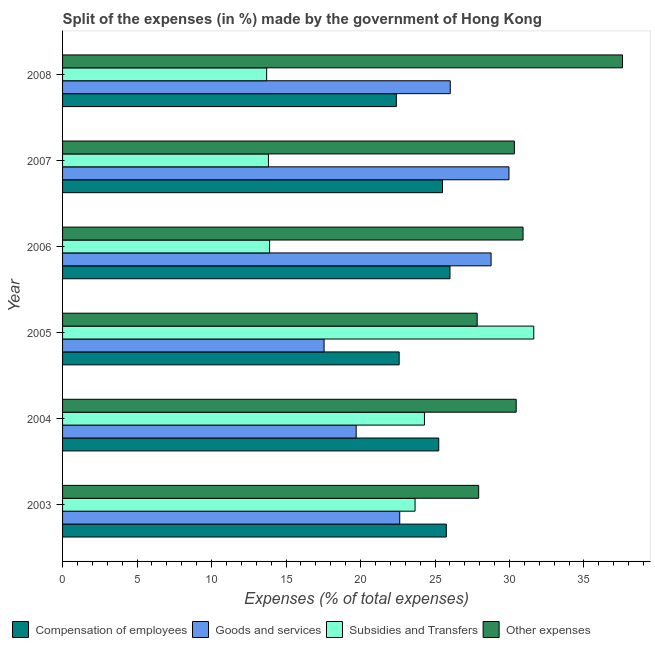How many different coloured bars are there?
Your response must be concise. 4. How many groups of bars are there?
Offer a terse response. 6. How many bars are there on the 5th tick from the bottom?
Ensure brevity in your answer.  4. In how many cases, is the number of bars for a given year not equal to the number of legend labels?
Keep it short and to the point. 0. What is the percentage of amount spent on goods and services in 2008?
Offer a terse response. 26.02. Across all years, what is the maximum percentage of amount spent on subsidies?
Your response must be concise. 31.63. Across all years, what is the minimum percentage of amount spent on other expenses?
Give a very brief answer. 27.83. In which year was the percentage of amount spent on compensation of employees maximum?
Make the answer very short. 2006. In which year was the percentage of amount spent on other expenses minimum?
Your response must be concise. 2005. What is the total percentage of amount spent on subsidies in the graph?
Offer a terse response. 121. What is the difference between the percentage of amount spent on subsidies in 2005 and that in 2008?
Your response must be concise. 17.93. What is the difference between the percentage of amount spent on subsidies in 2008 and the percentage of amount spent on other expenses in 2005?
Provide a succinct answer. -14.13. What is the average percentage of amount spent on subsidies per year?
Make the answer very short. 20.17. In the year 2006, what is the difference between the percentage of amount spent on subsidies and percentage of amount spent on other expenses?
Make the answer very short. -17.01. In how many years, is the percentage of amount spent on goods and services greater than 11 %?
Give a very brief answer. 6. Is the difference between the percentage of amount spent on goods and services in 2006 and 2007 greater than the difference between the percentage of amount spent on subsidies in 2006 and 2007?
Offer a very short reply. No. What is the difference between the highest and the second highest percentage of amount spent on goods and services?
Offer a terse response. 1.2. What is the difference between the highest and the lowest percentage of amount spent on goods and services?
Your answer should be compact. 12.41. Is it the case that in every year, the sum of the percentage of amount spent on compensation of employees and percentage of amount spent on goods and services is greater than the sum of percentage of amount spent on other expenses and percentage of amount spent on subsidies?
Your answer should be compact. Yes. What does the 2nd bar from the top in 2006 represents?
Keep it short and to the point. Subsidies and Transfers. What does the 1st bar from the bottom in 2004 represents?
Offer a very short reply. Compensation of employees. Is it the case that in every year, the sum of the percentage of amount spent on compensation of employees and percentage of amount spent on goods and services is greater than the percentage of amount spent on subsidies?
Your response must be concise. Yes. How many bars are there?
Make the answer very short. 24. Are all the bars in the graph horizontal?
Ensure brevity in your answer.  Yes. Does the graph contain grids?
Keep it short and to the point. No. Where does the legend appear in the graph?
Your response must be concise. Bottom left. What is the title of the graph?
Ensure brevity in your answer.  Split of the expenses (in %) made by the government of Hong Kong. Does "Greece" appear as one of the legend labels in the graph?
Keep it short and to the point. No. What is the label or title of the X-axis?
Give a very brief answer. Expenses (% of total expenses). What is the label or title of the Y-axis?
Keep it short and to the point. Year. What is the Expenses (% of total expenses) in Compensation of employees in 2003?
Your response must be concise. 25.76. What is the Expenses (% of total expenses) in Goods and services in 2003?
Make the answer very short. 22.63. What is the Expenses (% of total expenses) of Subsidies and Transfers in 2003?
Keep it short and to the point. 23.66. What is the Expenses (% of total expenses) in Other expenses in 2003?
Your answer should be compact. 27.93. What is the Expenses (% of total expenses) in Compensation of employees in 2004?
Offer a terse response. 25.25. What is the Expenses (% of total expenses) of Goods and services in 2004?
Your response must be concise. 19.71. What is the Expenses (% of total expenses) in Subsidies and Transfers in 2004?
Offer a terse response. 24.29. What is the Expenses (% of total expenses) of Other expenses in 2004?
Keep it short and to the point. 30.45. What is the Expenses (% of total expenses) in Compensation of employees in 2005?
Provide a succinct answer. 22.59. What is the Expenses (% of total expenses) of Goods and services in 2005?
Offer a very short reply. 17.56. What is the Expenses (% of total expenses) of Subsidies and Transfers in 2005?
Make the answer very short. 31.63. What is the Expenses (% of total expenses) of Other expenses in 2005?
Ensure brevity in your answer.  27.83. What is the Expenses (% of total expenses) in Compensation of employees in 2006?
Ensure brevity in your answer.  26.01. What is the Expenses (% of total expenses) in Goods and services in 2006?
Provide a succinct answer. 28.76. What is the Expenses (% of total expenses) in Subsidies and Transfers in 2006?
Your answer should be very brief. 13.9. What is the Expenses (% of total expenses) in Other expenses in 2006?
Offer a very short reply. 30.91. What is the Expenses (% of total expenses) in Compensation of employees in 2007?
Ensure brevity in your answer.  25.5. What is the Expenses (% of total expenses) of Goods and services in 2007?
Offer a very short reply. 29.97. What is the Expenses (% of total expenses) of Subsidies and Transfers in 2007?
Give a very brief answer. 13.82. What is the Expenses (% of total expenses) of Other expenses in 2007?
Your answer should be compact. 30.33. What is the Expenses (% of total expenses) of Compensation of employees in 2008?
Offer a very short reply. 22.41. What is the Expenses (% of total expenses) in Goods and services in 2008?
Your answer should be very brief. 26.02. What is the Expenses (% of total expenses) in Subsidies and Transfers in 2008?
Ensure brevity in your answer.  13.7. What is the Expenses (% of total expenses) in Other expenses in 2008?
Make the answer very short. 37.59. Across all years, what is the maximum Expenses (% of total expenses) in Compensation of employees?
Keep it short and to the point. 26.01. Across all years, what is the maximum Expenses (% of total expenses) in Goods and services?
Offer a very short reply. 29.97. Across all years, what is the maximum Expenses (% of total expenses) of Subsidies and Transfers?
Your answer should be compact. 31.63. Across all years, what is the maximum Expenses (% of total expenses) in Other expenses?
Your answer should be compact. 37.59. Across all years, what is the minimum Expenses (% of total expenses) of Compensation of employees?
Your answer should be very brief. 22.41. Across all years, what is the minimum Expenses (% of total expenses) of Goods and services?
Provide a short and direct response. 17.56. Across all years, what is the minimum Expenses (% of total expenses) of Subsidies and Transfers?
Provide a short and direct response. 13.7. Across all years, what is the minimum Expenses (% of total expenses) in Other expenses?
Offer a terse response. 27.83. What is the total Expenses (% of total expenses) in Compensation of employees in the graph?
Ensure brevity in your answer.  147.52. What is the total Expenses (% of total expenses) in Goods and services in the graph?
Make the answer very short. 144.65. What is the total Expenses (% of total expenses) in Subsidies and Transfers in the graph?
Keep it short and to the point. 121. What is the total Expenses (% of total expenses) in Other expenses in the graph?
Your response must be concise. 185.04. What is the difference between the Expenses (% of total expenses) of Compensation of employees in 2003 and that in 2004?
Give a very brief answer. 0.51. What is the difference between the Expenses (% of total expenses) in Goods and services in 2003 and that in 2004?
Your response must be concise. 2.92. What is the difference between the Expenses (% of total expenses) in Subsidies and Transfers in 2003 and that in 2004?
Offer a very short reply. -0.63. What is the difference between the Expenses (% of total expenses) in Other expenses in 2003 and that in 2004?
Offer a terse response. -2.52. What is the difference between the Expenses (% of total expenses) of Compensation of employees in 2003 and that in 2005?
Your response must be concise. 3.17. What is the difference between the Expenses (% of total expenses) of Goods and services in 2003 and that in 2005?
Provide a short and direct response. 5.08. What is the difference between the Expenses (% of total expenses) in Subsidies and Transfers in 2003 and that in 2005?
Your response must be concise. -7.97. What is the difference between the Expenses (% of total expenses) in Other expenses in 2003 and that in 2005?
Provide a short and direct response. 0.1. What is the difference between the Expenses (% of total expenses) of Compensation of employees in 2003 and that in 2006?
Your answer should be compact. -0.25. What is the difference between the Expenses (% of total expenses) in Goods and services in 2003 and that in 2006?
Make the answer very short. -6.13. What is the difference between the Expenses (% of total expenses) in Subsidies and Transfers in 2003 and that in 2006?
Your answer should be very brief. 9.76. What is the difference between the Expenses (% of total expenses) in Other expenses in 2003 and that in 2006?
Your answer should be compact. -2.98. What is the difference between the Expenses (% of total expenses) of Compensation of employees in 2003 and that in 2007?
Keep it short and to the point. 0.26. What is the difference between the Expenses (% of total expenses) of Goods and services in 2003 and that in 2007?
Provide a succinct answer. -7.33. What is the difference between the Expenses (% of total expenses) in Subsidies and Transfers in 2003 and that in 2007?
Offer a very short reply. 9.84. What is the difference between the Expenses (% of total expenses) in Other expenses in 2003 and that in 2007?
Offer a very short reply. -2.39. What is the difference between the Expenses (% of total expenses) of Compensation of employees in 2003 and that in 2008?
Provide a succinct answer. 3.36. What is the difference between the Expenses (% of total expenses) of Goods and services in 2003 and that in 2008?
Make the answer very short. -3.39. What is the difference between the Expenses (% of total expenses) of Subsidies and Transfers in 2003 and that in 2008?
Keep it short and to the point. 9.96. What is the difference between the Expenses (% of total expenses) of Other expenses in 2003 and that in 2008?
Provide a succinct answer. -9.65. What is the difference between the Expenses (% of total expenses) in Compensation of employees in 2004 and that in 2005?
Provide a short and direct response. 2.66. What is the difference between the Expenses (% of total expenses) of Goods and services in 2004 and that in 2005?
Make the answer very short. 2.15. What is the difference between the Expenses (% of total expenses) in Subsidies and Transfers in 2004 and that in 2005?
Keep it short and to the point. -7.34. What is the difference between the Expenses (% of total expenses) of Other expenses in 2004 and that in 2005?
Ensure brevity in your answer.  2.62. What is the difference between the Expenses (% of total expenses) in Compensation of employees in 2004 and that in 2006?
Make the answer very short. -0.76. What is the difference between the Expenses (% of total expenses) in Goods and services in 2004 and that in 2006?
Offer a very short reply. -9.05. What is the difference between the Expenses (% of total expenses) in Subsidies and Transfers in 2004 and that in 2006?
Your answer should be compact. 10.39. What is the difference between the Expenses (% of total expenses) of Other expenses in 2004 and that in 2006?
Your answer should be very brief. -0.46. What is the difference between the Expenses (% of total expenses) in Compensation of employees in 2004 and that in 2007?
Give a very brief answer. -0.25. What is the difference between the Expenses (% of total expenses) of Goods and services in 2004 and that in 2007?
Your response must be concise. -10.26. What is the difference between the Expenses (% of total expenses) of Subsidies and Transfers in 2004 and that in 2007?
Your answer should be compact. 10.47. What is the difference between the Expenses (% of total expenses) of Other expenses in 2004 and that in 2007?
Offer a terse response. 0.12. What is the difference between the Expenses (% of total expenses) in Compensation of employees in 2004 and that in 2008?
Give a very brief answer. 2.85. What is the difference between the Expenses (% of total expenses) of Goods and services in 2004 and that in 2008?
Offer a very short reply. -6.32. What is the difference between the Expenses (% of total expenses) in Subsidies and Transfers in 2004 and that in 2008?
Your response must be concise. 10.59. What is the difference between the Expenses (% of total expenses) of Other expenses in 2004 and that in 2008?
Make the answer very short. -7.13. What is the difference between the Expenses (% of total expenses) of Compensation of employees in 2005 and that in 2006?
Offer a very short reply. -3.41. What is the difference between the Expenses (% of total expenses) in Goods and services in 2005 and that in 2006?
Give a very brief answer. -11.21. What is the difference between the Expenses (% of total expenses) of Subsidies and Transfers in 2005 and that in 2006?
Provide a succinct answer. 17.73. What is the difference between the Expenses (% of total expenses) of Other expenses in 2005 and that in 2006?
Your answer should be very brief. -3.08. What is the difference between the Expenses (% of total expenses) of Compensation of employees in 2005 and that in 2007?
Give a very brief answer. -2.91. What is the difference between the Expenses (% of total expenses) in Goods and services in 2005 and that in 2007?
Keep it short and to the point. -12.41. What is the difference between the Expenses (% of total expenses) of Subsidies and Transfers in 2005 and that in 2007?
Provide a short and direct response. 17.81. What is the difference between the Expenses (% of total expenses) of Other expenses in 2005 and that in 2007?
Make the answer very short. -2.5. What is the difference between the Expenses (% of total expenses) of Compensation of employees in 2005 and that in 2008?
Give a very brief answer. 0.19. What is the difference between the Expenses (% of total expenses) of Goods and services in 2005 and that in 2008?
Your response must be concise. -8.47. What is the difference between the Expenses (% of total expenses) of Subsidies and Transfers in 2005 and that in 2008?
Offer a very short reply. 17.93. What is the difference between the Expenses (% of total expenses) of Other expenses in 2005 and that in 2008?
Your response must be concise. -9.76. What is the difference between the Expenses (% of total expenses) of Compensation of employees in 2006 and that in 2007?
Keep it short and to the point. 0.5. What is the difference between the Expenses (% of total expenses) in Goods and services in 2006 and that in 2007?
Ensure brevity in your answer.  -1.2. What is the difference between the Expenses (% of total expenses) of Subsidies and Transfers in 2006 and that in 2007?
Your answer should be compact. 0.08. What is the difference between the Expenses (% of total expenses) of Other expenses in 2006 and that in 2007?
Your response must be concise. 0.58. What is the difference between the Expenses (% of total expenses) of Compensation of employees in 2006 and that in 2008?
Provide a short and direct response. 3.6. What is the difference between the Expenses (% of total expenses) in Goods and services in 2006 and that in 2008?
Offer a terse response. 2.74. What is the difference between the Expenses (% of total expenses) in Subsidies and Transfers in 2006 and that in 2008?
Provide a succinct answer. 0.2. What is the difference between the Expenses (% of total expenses) in Other expenses in 2006 and that in 2008?
Keep it short and to the point. -6.68. What is the difference between the Expenses (% of total expenses) in Compensation of employees in 2007 and that in 2008?
Your response must be concise. 3.1. What is the difference between the Expenses (% of total expenses) in Goods and services in 2007 and that in 2008?
Provide a succinct answer. 3.94. What is the difference between the Expenses (% of total expenses) in Subsidies and Transfers in 2007 and that in 2008?
Provide a short and direct response. 0.12. What is the difference between the Expenses (% of total expenses) of Other expenses in 2007 and that in 2008?
Give a very brief answer. -7.26. What is the difference between the Expenses (% of total expenses) in Compensation of employees in 2003 and the Expenses (% of total expenses) in Goods and services in 2004?
Provide a succinct answer. 6.05. What is the difference between the Expenses (% of total expenses) of Compensation of employees in 2003 and the Expenses (% of total expenses) of Subsidies and Transfers in 2004?
Offer a terse response. 1.47. What is the difference between the Expenses (% of total expenses) of Compensation of employees in 2003 and the Expenses (% of total expenses) of Other expenses in 2004?
Your response must be concise. -4.69. What is the difference between the Expenses (% of total expenses) in Goods and services in 2003 and the Expenses (% of total expenses) in Subsidies and Transfers in 2004?
Offer a terse response. -1.66. What is the difference between the Expenses (% of total expenses) of Goods and services in 2003 and the Expenses (% of total expenses) of Other expenses in 2004?
Give a very brief answer. -7.82. What is the difference between the Expenses (% of total expenses) in Subsidies and Transfers in 2003 and the Expenses (% of total expenses) in Other expenses in 2004?
Provide a short and direct response. -6.79. What is the difference between the Expenses (% of total expenses) of Compensation of employees in 2003 and the Expenses (% of total expenses) of Goods and services in 2005?
Provide a short and direct response. 8.21. What is the difference between the Expenses (% of total expenses) of Compensation of employees in 2003 and the Expenses (% of total expenses) of Subsidies and Transfers in 2005?
Offer a very short reply. -5.87. What is the difference between the Expenses (% of total expenses) in Compensation of employees in 2003 and the Expenses (% of total expenses) in Other expenses in 2005?
Ensure brevity in your answer.  -2.07. What is the difference between the Expenses (% of total expenses) in Goods and services in 2003 and the Expenses (% of total expenses) in Subsidies and Transfers in 2005?
Offer a very short reply. -9. What is the difference between the Expenses (% of total expenses) of Goods and services in 2003 and the Expenses (% of total expenses) of Other expenses in 2005?
Provide a short and direct response. -5.2. What is the difference between the Expenses (% of total expenses) of Subsidies and Transfers in 2003 and the Expenses (% of total expenses) of Other expenses in 2005?
Your response must be concise. -4.17. What is the difference between the Expenses (% of total expenses) in Compensation of employees in 2003 and the Expenses (% of total expenses) in Goods and services in 2006?
Offer a terse response. -3. What is the difference between the Expenses (% of total expenses) in Compensation of employees in 2003 and the Expenses (% of total expenses) in Subsidies and Transfers in 2006?
Keep it short and to the point. 11.86. What is the difference between the Expenses (% of total expenses) of Compensation of employees in 2003 and the Expenses (% of total expenses) of Other expenses in 2006?
Your answer should be compact. -5.15. What is the difference between the Expenses (% of total expenses) in Goods and services in 2003 and the Expenses (% of total expenses) in Subsidies and Transfers in 2006?
Keep it short and to the point. 8.73. What is the difference between the Expenses (% of total expenses) of Goods and services in 2003 and the Expenses (% of total expenses) of Other expenses in 2006?
Keep it short and to the point. -8.28. What is the difference between the Expenses (% of total expenses) of Subsidies and Transfers in 2003 and the Expenses (% of total expenses) of Other expenses in 2006?
Ensure brevity in your answer.  -7.25. What is the difference between the Expenses (% of total expenses) in Compensation of employees in 2003 and the Expenses (% of total expenses) in Goods and services in 2007?
Provide a short and direct response. -4.2. What is the difference between the Expenses (% of total expenses) in Compensation of employees in 2003 and the Expenses (% of total expenses) in Subsidies and Transfers in 2007?
Provide a succinct answer. 11.94. What is the difference between the Expenses (% of total expenses) in Compensation of employees in 2003 and the Expenses (% of total expenses) in Other expenses in 2007?
Provide a short and direct response. -4.57. What is the difference between the Expenses (% of total expenses) of Goods and services in 2003 and the Expenses (% of total expenses) of Subsidies and Transfers in 2007?
Your response must be concise. 8.81. What is the difference between the Expenses (% of total expenses) of Goods and services in 2003 and the Expenses (% of total expenses) of Other expenses in 2007?
Offer a terse response. -7.69. What is the difference between the Expenses (% of total expenses) in Subsidies and Transfers in 2003 and the Expenses (% of total expenses) in Other expenses in 2007?
Offer a very short reply. -6.67. What is the difference between the Expenses (% of total expenses) in Compensation of employees in 2003 and the Expenses (% of total expenses) in Goods and services in 2008?
Provide a succinct answer. -0.26. What is the difference between the Expenses (% of total expenses) of Compensation of employees in 2003 and the Expenses (% of total expenses) of Subsidies and Transfers in 2008?
Ensure brevity in your answer.  12.06. What is the difference between the Expenses (% of total expenses) in Compensation of employees in 2003 and the Expenses (% of total expenses) in Other expenses in 2008?
Ensure brevity in your answer.  -11.83. What is the difference between the Expenses (% of total expenses) of Goods and services in 2003 and the Expenses (% of total expenses) of Subsidies and Transfers in 2008?
Provide a succinct answer. 8.93. What is the difference between the Expenses (% of total expenses) in Goods and services in 2003 and the Expenses (% of total expenses) in Other expenses in 2008?
Your response must be concise. -14.95. What is the difference between the Expenses (% of total expenses) in Subsidies and Transfers in 2003 and the Expenses (% of total expenses) in Other expenses in 2008?
Keep it short and to the point. -13.92. What is the difference between the Expenses (% of total expenses) in Compensation of employees in 2004 and the Expenses (% of total expenses) in Goods and services in 2005?
Provide a short and direct response. 7.7. What is the difference between the Expenses (% of total expenses) in Compensation of employees in 2004 and the Expenses (% of total expenses) in Subsidies and Transfers in 2005?
Offer a very short reply. -6.38. What is the difference between the Expenses (% of total expenses) in Compensation of employees in 2004 and the Expenses (% of total expenses) in Other expenses in 2005?
Offer a terse response. -2.58. What is the difference between the Expenses (% of total expenses) of Goods and services in 2004 and the Expenses (% of total expenses) of Subsidies and Transfers in 2005?
Make the answer very short. -11.92. What is the difference between the Expenses (% of total expenses) in Goods and services in 2004 and the Expenses (% of total expenses) in Other expenses in 2005?
Your answer should be very brief. -8.12. What is the difference between the Expenses (% of total expenses) of Subsidies and Transfers in 2004 and the Expenses (% of total expenses) of Other expenses in 2005?
Give a very brief answer. -3.54. What is the difference between the Expenses (% of total expenses) in Compensation of employees in 2004 and the Expenses (% of total expenses) in Goods and services in 2006?
Your answer should be compact. -3.51. What is the difference between the Expenses (% of total expenses) in Compensation of employees in 2004 and the Expenses (% of total expenses) in Subsidies and Transfers in 2006?
Your answer should be compact. 11.35. What is the difference between the Expenses (% of total expenses) in Compensation of employees in 2004 and the Expenses (% of total expenses) in Other expenses in 2006?
Offer a terse response. -5.66. What is the difference between the Expenses (% of total expenses) in Goods and services in 2004 and the Expenses (% of total expenses) in Subsidies and Transfers in 2006?
Make the answer very short. 5.81. What is the difference between the Expenses (% of total expenses) in Goods and services in 2004 and the Expenses (% of total expenses) in Other expenses in 2006?
Ensure brevity in your answer.  -11.2. What is the difference between the Expenses (% of total expenses) in Subsidies and Transfers in 2004 and the Expenses (% of total expenses) in Other expenses in 2006?
Make the answer very short. -6.62. What is the difference between the Expenses (% of total expenses) of Compensation of employees in 2004 and the Expenses (% of total expenses) of Goods and services in 2007?
Ensure brevity in your answer.  -4.71. What is the difference between the Expenses (% of total expenses) of Compensation of employees in 2004 and the Expenses (% of total expenses) of Subsidies and Transfers in 2007?
Make the answer very short. 11.43. What is the difference between the Expenses (% of total expenses) of Compensation of employees in 2004 and the Expenses (% of total expenses) of Other expenses in 2007?
Provide a short and direct response. -5.08. What is the difference between the Expenses (% of total expenses) in Goods and services in 2004 and the Expenses (% of total expenses) in Subsidies and Transfers in 2007?
Your response must be concise. 5.89. What is the difference between the Expenses (% of total expenses) of Goods and services in 2004 and the Expenses (% of total expenses) of Other expenses in 2007?
Give a very brief answer. -10.62. What is the difference between the Expenses (% of total expenses) of Subsidies and Transfers in 2004 and the Expenses (% of total expenses) of Other expenses in 2007?
Your answer should be very brief. -6.03. What is the difference between the Expenses (% of total expenses) of Compensation of employees in 2004 and the Expenses (% of total expenses) of Goods and services in 2008?
Keep it short and to the point. -0.77. What is the difference between the Expenses (% of total expenses) in Compensation of employees in 2004 and the Expenses (% of total expenses) in Subsidies and Transfers in 2008?
Ensure brevity in your answer.  11.55. What is the difference between the Expenses (% of total expenses) in Compensation of employees in 2004 and the Expenses (% of total expenses) in Other expenses in 2008?
Provide a short and direct response. -12.34. What is the difference between the Expenses (% of total expenses) in Goods and services in 2004 and the Expenses (% of total expenses) in Subsidies and Transfers in 2008?
Give a very brief answer. 6.01. What is the difference between the Expenses (% of total expenses) of Goods and services in 2004 and the Expenses (% of total expenses) of Other expenses in 2008?
Ensure brevity in your answer.  -17.88. What is the difference between the Expenses (% of total expenses) in Subsidies and Transfers in 2004 and the Expenses (% of total expenses) in Other expenses in 2008?
Your response must be concise. -13.29. What is the difference between the Expenses (% of total expenses) of Compensation of employees in 2005 and the Expenses (% of total expenses) of Goods and services in 2006?
Make the answer very short. -6.17. What is the difference between the Expenses (% of total expenses) in Compensation of employees in 2005 and the Expenses (% of total expenses) in Subsidies and Transfers in 2006?
Ensure brevity in your answer.  8.7. What is the difference between the Expenses (% of total expenses) in Compensation of employees in 2005 and the Expenses (% of total expenses) in Other expenses in 2006?
Offer a very short reply. -8.32. What is the difference between the Expenses (% of total expenses) in Goods and services in 2005 and the Expenses (% of total expenses) in Subsidies and Transfers in 2006?
Offer a very short reply. 3.66. What is the difference between the Expenses (% of total expenses) of Goods and services in 2005 and the Expenses (% of total expenses) of Other expenses in 2006?
Your answer should be very brief. -13.35. What is the difference between the Expenses (% of total expenses) of Subsidies and Transfers in 2005 and the Expenses (% of total expenses) of Other expenses in 2006?
Make the answer very short. 0.72. What is the difference between the Expenses (% of total expenses) in Compensation of employees in 2005 and the Expenses (% of total expenses) in Goods and services in 2007?
Ensure brevity in your answer.  -7.37. What is the difference between the Expenses (% of total expenses) in Compensation of employees in 2005 and the Expenses (% of total expenses) in Subsidies and Transfers in 2007?
Offer a very short reply. 8.78. What is the difference between the Expenses (% of total expenses) in Compensation of employees in 2005 and the Expenses (% of total expenses) in Other expenses in 2007?
Keep it short and to the point. -7.73. What is the difference between the Expenses (% of total expenses) in Goods and services in 2005 and the Expenses (% of total expenses) in Subsidies and Transfers in 2007?
Keep it short and to the point. 3.74. What is the difference between the Expenses (% of total expenses) in Goods and services in 2005 and the Expenses (% of total expenses) in Other expenses in 2007?
Your answer should be compact. -12.77. What is the difference between the Expenses (% of total expenses) of Subsidies and Transfers in 2005 and the Expenses (% of total expenses) of Other expenses in 2007?
Give a very brief answer. 1.3. What is the difference between the Expenses (% of total expenses) in Compensation of employees in 2005 and the Expenses (% of total expenses) in Goods and services in 2008?
Make the answer very short. -3.43. What is the difference between the Expenses (% of total expenses) in Compensation of employees in 2005 and the Expenses (% of total expenses) in Subsidies and Transfers in 2008?
Provide a succinct answer. 8.89. What is the difference between the Expenses (% of total expenses) of Compensation of employees in 2005 and the Expenses (% of total expenses) of Other expenses in 2008?
Keep it short and to the point. -14.99. What is the difference between the Expenses (% of total expenses) in Goods and services in 2005 and the Expenses (% of total expenses) in Subsidies and Transfers in 2008?
Give a very brief answer. 3.86. What is the difference between the Expenses (% of total expenses) of Goods and services in 2005 and the Expenses (% of total expenses) of Other expenses in 2008?
Give a very brief answer. -20.03. What is the difference between the Expenses (% of total expenses) in Subsidies and Transfers in 2005 and the Expenses (% of total expenses) in Other expenses in 2008?
Keep it short and to the point. -5.96. What is the difference between the Expenses (% of total expenses) in Compensation of employees in 2006 and the Expenses (% of total expenses) in Goods and services in 2007?
Offer a very short reply. -3.96. What is the difference between the Expenses (% of total expenses) in Compensation of employees in 2006 and the Expenses (% of total expenses) in Subsidies and Transfers in 2007?
Provide a short and direct response. 12.19. What is the difference between the Expenses (% of total expenses) in Compensation of employees in 2006 and the Expenses (% of total expenses) in Other expenses in 2007?
Your answer should be very brief. -4.32. What is the difference between the Expenses (% of total expenses) in Goods and services in 2006 and the Expenses (% of total expenses) in Subsidies and Transfers in 2007?
Make the answer very short. 14.94. What is the difference between the Expenses (% of total expenses) in Goods and services in 2006 and the Expenses (% of total expenses) in Other expenses in 2007?
Keep it short and to the point. -1.56. What is the difference between the Expenses (% of total expenses) of Subsidies and Transfers in 2006 and the Expenses (% of total expenses) of Other expenses in 2007?
Offer a terse response. -16.43. What is the difference between the Expenses (% of total expenses) in Compensation of employees in 2006 and the Expenses (% of total expenses) in Goods and services in 2008?
Offer a very short reply. -0.02. What is the difference between the Expenses (% of total expenses) of Compensation of employees in 2006 and the Expenses (% of total expenses) of Subsidies and Transfers in 2008?
Give a very brief answer. 12.31. What is the difference between the Expenses (% of total expenses) in Compensation of employees in 2006 and the Expenses (% of total expenses) in Other expenses in 2008?
Make the answer very short. -11.58. What is the difference between the Expenses (% of total expenses) in Goods and services in 2006 and the Expenses (% of total expenses) in Subsidies and Transfers in 2008?
Offer a very short reply. 15.06. What is the difference between the Expenses (% of total expenses) of Goods and services in 2006 and the Expenses (% of total expenses) of Other expenses in 2008?
Make the answer very short. -8.82. What is the difference between the Expenses (% of total expenses) in Subsidies and Transfers in 2006 and the Expenses (% of total expenses) in Other expenses in 2008?
Your answer should be compact. -23.69. What is the difference between the Expenses (% of total expenses) of Compensation of employees in 2007 and the Expenses (% of total expenses) of Goods and services in 2008?
Offer a terse response. -0.52. What is the difference between the Expenses (% of total expenses) in Compensation of employees in 2007 and the Expenses (% of total expenses) in Subsidies and Transfers in 2008?
Your answer should be compact. 11.8. What is the difference between the Expenses (% of total expenses) of Compensation of employees in 2007 and the Expenses (% of total expenses) of Other expenses in 2008?
Offer a terse response. -12.08. What is the difference between the Expenses (% of total expenses) of Goods and services in 2007 and the Expenses (% of total expenses) of Subsidies and Transfers in 2008?
Ensure brevity in your answer.  16.27. What is the difference between the Expenses (% of total expenses) of Goods and services in 2007 and the Expenses (% of total expenses) of Other expenses in 2008?
Make the answer very short. -7.62. What is the difference between the Expenses (% of total expenses) of Subsidies and Transfers in 2007 and the Expenses (% of total expenses) of Other expenses in 2008?
Offer a terse response. -23.77. What is the average Expenses (% of total expenses) of Compensation of employees per year?
Ensure brevity in your answer.  24.59. What is the average Expenses (% of total expenses) in Goods and services per year?
Keep it short and to the point. 24.11. What is the average Expenses (% of total expenses) in Subsidies and Transfers per year?
Offer a very short reply. 20.17. What is the average Expenses (% of total expenses) in Other expenses per year?
Make the answer very short. 30.84. In the year 2003, what is the difference between the Expenses (% of total expenses) in Compensation of employees and Expenses (% of total expenses) in Goods and services?
Make the answer very short. 3.13. In the year 2003, what is the difference between the Expenses (% of total expenses) in Compensation of employees and Expenses (% of total expenses) in Subsidies and Transfers?
Offer a terse response. 2.1. In the year 2003, what is the difference between the Expenses (% of total expenses) in Compensation of employees and Expenses (% of total expenses) in Other expenses?
Keep it short and to the point. -2.17. In the year 2003, what is the difference between the Expenses (% of total expenses) in Goods and services and Expenses (% of total expenses) in Subsidies and Transfers?
Offer a terse response. -1.03. In the year 2003, what is the difference between the Expenses (% of total expenses) of Goods and services and Expenses (% of total expenses) of Other expenses?
Your response must be concise. -5.3. In the year 2003, what is the difference between the Expenses (% of total expenses) in Subsidies and Transfers and Expenses (% of total expenses) in Other expenses?
Offer a very short reply. -4.27. In the year 2004, what is the difference between the Expenses (% of total expenses) of Compensation of employees and Expenses (% of total expenses) of Goods and services?
Provide a succinct answer. 5.54. In the year 2004, what is the difference between the Expenses (% of total expenses) of Compensation of employees and Expenses (% of total expenses) of Subsidies and Transfers?
Give a very brief answer. 0.96. In the year 2004, what is the difference between the Expenses (% of total expenses) in Compensation of employees and Expenses (% of total expenses) in Other expenses?
Your answer should be very brief. -5.2. In the year 2004, what is the difference between the Expenses (% of total expenses) of Goods and services and Expenses (% of total expenses) of Subsidies and Transfers?
Make the answer very short. -4.58. In the year 2004, what is the difference between the Expenses (% of total expenses) of Goods and services and Expenses (% of total expenses) of Other expenses?
Your response must be concise. -10.74. In the year 2004, what is the difference between the Expenses (% of total expenses) in Subsidies and Transfers and Expenses (% of total expenses) in Other expenses?
Offer a very short reply. -6.16. In the year 2005, what is the difference between the Expenses (% of total expenses) of Compensation of employees and Expenses (% of total expenses) of Goods and services?
Your response must be concise. 5.04. In the year 2005, what is the difference between the Expenses (% of total expenses) of Compensation of employees and Expenses (% of total expenses) of Subsidies and Transfers?
Your answer should be compact. -9.04. In the year 2005, what is the difference between the Expenses (% of total expenses) of Compensation of employees and Expenses (% of total expenses) of Other expenses?
Your answer should be compact. -5.24. In the year 2005, what is the difference between the Expenses (% of total expenses) in Goods and services and Expenses (% of total expenses) in Subsidies and Transfers?
Your answer should be very brief. -14.07. In the year 2005, what is the difference between the Expenses (% of total expenses) of Goods and services and Expenses (% of total expenses) of Other expenses?
Your answer should be very brief. -10.28. In the year 2005, what is the difference between the Expenses (% of total expenses) in Subsidies and Transfers and Expenses (% of total expenses) in Other expenses?
Provide a succinct answer. 3.8. In the year 2006, what is the difference between the Expenses (% of total expenses) of Compensation of employees and Expenses (% of total expenses) of Goods and services?
Provide a succinct answer. -2.76. In the year 2006, what is the difference between the Expenses (% of total expenses) of Compensation of employees and Expenses (% of total expenses) of Subsidies and Transfers?
Your answer should be very brief. 12.11. In the year 2006, what is the difference between the Expenses (% of total expenses) in Compensation of employees and Expenses (% of total expenses) in Other expenses?
Ensure brevity in your answer.  -4.9. In the year 2006, what is the difference between the Expenses (% of total expenses) in Goods and services and Expenses (% of total expenses) in Subsidies and Transfers?
Provide a short and direct response. 14.87. In the year 2006, what is the difference between the Expenses (% of total expenses) of Goods and services and Expenses (% of total expenses) of Other expenses?
Your response must be concise. -2.15. In the year 2006, what is the difference between the Expenses (% of total expenses) in Subsidies and Transfers and Expenses (% of total expenses) in Other expenses?
Offer a terse response. -17.01. In the year 2007, what is the difference between the Expenses (% of total expenses) of Compensation of employees and Expenses (% of total expenses) of Goods and services?
Make the answer very short. -4.46. In the year 2007, what is the difference between the Expenses (% of total expenses) in Compensation of employees and Expenses (% of total expenses) in Subsidies and Transfers?
Give a very brief answer. 11.68. In the year 2007, what is the difference between the Expenses (% of total expenses) in Compensation of employees and Expenses (% of total expenses) in Other expenses?
Provide a short and direct response. -4.82. In the year 2007, what is the difference between the Expenses (% of total expenses) of Goods and services and Expenses (% of total expenses) of Subsidies and Transfers?
Your answer should be very brief. 16.15. In the year 2007, what is the difference between the Expenses (% of total expenses) in Goods and services and Expenses (% of total expenses) in Other expenses?
Offer a terse response. -0.36. In the year 2007, what is the difference between the Expenses (% of total expenses) in Subsidies and Transfers and Expenses (% of total expenses) in Other expenses?
Offer a terse response. -16.51. In the year 2008, what is the difference between the Expenses (% of total expenses) in Compensation of employees and Expenses (% of total expenses) in Goods and services?
Offer a terse response. -3.62. In the year 2008, what is the difference between the Expenses (% of total expenses) in Compensation of employees and Expenses (% of total expenses) in Subsidies and Transfers?
Provide a short and direct response. 8.71. In the year 2008, what is the difference between the Expenses (% of total expenses) of Compensation of employees and Expenses (% of total expenses) of Other expenses?
Ensure brevity in your answer.  -15.18. In the year 2008, what is the difference between the Expenses (% of total expenses) of Goods and services and Expenses (% of total expenses) of Subsidies and Transfers?
Offer a terse response. 12.32. In the year 2008, what is the difference between the Expenses (% of total expenses) of Goods and services and Expenses (% of total expenses) of Other expenses?
Offer a terse response. -11.56. In the year 2008, what is the difference between the Expenses (% of total expenses) in Subsidies and Transfers and Expenses (% of total expenses) in Other expenses?
Your response must be concise. -23.89. What is the ratio of the Expenses (% of total expenses) in Compensation of employees in 2003 to that in 2004?
Offer a very short reply. 1.02. What is the ratio of the Expenses (% of total expenses) in Goods and services in 2003 to that in 2004?
Ensure brevity in your answer.  1.15. What is the ratio of the Expenses (% of total expenses) of Subsidies and Transfers in 2003 to that in 2004?
Give a very brief answer. 0.97. What is the ratio of the Expenses (% of total expenses) in Other expenses in 2003 to that in 2004?
Make the answer very short. 0.92. What is the ratio of the Expenses (% of total expenses) of Compensation of employees in 2003 to that in 2005?
Offer a very short reply. 1.14. What is the ratio of the Expenses (% of total expenses) of Goods and services in 2003 to that in 2005?
Give a very brief answer. 1.29. What is the ratio of the Expenses (% of total expenses) of Subsidies and Transfers in 2003 to that in 2005?
Provide a succinct answer. 0.75. What is the ratio of the Expenses (% of total expenses) of Other expenses in 2003 to that in 2005?
Your answer should be compact. 1. What is the ratio of the Expenses (% of total expenses) of Compensation of employees in 2003 to that in 2006?
Provide a short and direct response. 0.99. What is the ratio of the Expenses (% of total expenses) of Goods and services in 2003 to that in 2006?
Provide a short and direct response. 0.79. What is the ratio of the Expenses (% of total expenses) in Subsidies and Transfers in 2003 to that in 2006?
Offer a very short reply. 1.7. What is the ratio of the Expenses (% of total expenses) in Other expenses in 2003 to that in 2006?
Provide a short and direct response. 0.9. What is the ratio of the Expenses (% of total expenses) of Goods and services in 2003 to that in 2007?
Provide a succinct answer. 0.76. What is the ratio of the Expenses (% of total expenses) of Subsidies and Transfers in 2003 to that in 2007?
Your answer should be compact. 1.71. What is the ratio of the Expenses (% of total expenses) of Other expenses in 2003 to that in 2007?
Provide a succinct answer. 0.92. What is the ratio of the Expenses (% of total expenses) of Compensation of employees in 2003 to that in 2008?
Provide a short and direct response. 1.15. What is the ratio of the Expenses (% of total expenses) of Goods and services in 2003 to that in 2008?
Ensure brevity in your answer.  0.87. What is the ratio of the Expenses (% of total expenses) of Subsidies and Transfers in 2003 to that in 2008?
Your answer should be compact. 1.73. What is the ratio of the Expenses (% of total expenses) of Other expenses in 2003 to that in 2008?
Provide a short and direct response. 0.74. What is the ratio of the Expenses (% of total expenses) in Compensation of employees in 2004 to that in 2005?
Offer a terse response. 1.12. What is the ratio of the Expenses (% of total expenses) of Goods and services in 2004 to that in 2005?
Make the answer very short. 1.12. What is the ratio of the Expenses (% of total expenses) of Subsidies and Transfers in 2004 to that in 2005?
Ensure brevity in your answer.  0.77. What is the ratio of the Expenses (% of total expenses) in Other expenses in 2004 to that in 2005?
Your answer should be compact. 1.09. What is the ratio of the Expenses (% of total expenses) in Goods and services in 2004 to that in 2006?
Give a very brief answer. 0.69. What is the ratio of the Expenses (% of total expenses) in Subsidies and Transfers in 2004 to that in 2006?
Offer a terse response. 1.75. What is the ratio of the Expenses (% of total expenses) of Other expenses in 2004 to that in 2006?
Ensure brevity in your answer.  0.99. What is the ratio of the Expenses (% of total expenses) of Compensation of employees in 2004 to that in 2007?
Offer a terse response. 0.99. What is the ratio of the Expenses (% of total expenses) of Goods and services in 2004 to that in 2007?
Ensure brevity in your answer.  0.66. What is the ratio of the Expenses (% of total expenses) in Subsidies and Transfers in 2004 to that in 2007?
Make the answer very short. 1.76. What is the ratio of the Expenses (% of total expenses) of Other expenses in 2004 to that in 2007?
Your answer should be compact. 1. What is the ratio of the Expenses (% of total expenses) of Compensation of employees in 2004 to that in 2008?
Provide a short and direct response. 1.13. What is the ratio of the Expenses (% of total expenses) of Goods and services in 2004 to that in 2008?
Ensure brevity in your answer.  0.76. What is the ratio of the Expenses (% of total expenses) in Subsidies and Transfers in 2004 to that in 2008?
Offer a very short reply. 1.77. What is the ratio of the Expenses (% of total expenses) in Other expenses in 2004 to that in 2008?
Offer a very short reply. 0.81. What is the ratio of the Expenses (% of total expenses) in Compensation of employees in 2005 to that in 2006?
Make the answer very short. 0.87. What is the ratio of the Expenses (% of total expenses) of Goods and services in 2005 to that in 2006?
Offer a terse response. 0.61. What is the ratio of the Expenses (% of total expenses) in Subsidies and Transfers in 2005 to that in 2006?
Offer a very short reply. 2.28. What is the ratio of the Expenses (% of total expenses) in Other expenses in 2005 to that in 2006?
Make the answer very short. 0.9. What is the ratio of the Expenses (% of total expenses) in Compensation of employees in 2005 to that in 2007?
Ensure brevity in your answer.  0.89. What is the ratio of the Expenses (% of total expenses) in Goods and services in 2005 to that in 2007?
Your answer should be very brief. 0.59. What is the ratio of the Expenses (% of total expenses) in Subsidies and Transfers in 2005 to that in 2007?
Your answer should be very brief. 2.29. What is the ratio of the Expenses (% of total expenses) in Other expenses in 2005 to that in 2007?
Your response must be concise. 0.92. What is the ratio of the Expenses (% of total expenses) of Compensation of employees in 2005 to that in 2008?
Offer a very short reply. 1.01. What is the ratio of the Expenses (% of total expenses) in Goods and services in 2005 to that in 2008?
Give a very brief answer. 0.67. What is the ratio of the Expenses (% of total expenses) of Subsidies and Transfers in 2005 to that in 2008?
Offer a very short reply. 2.31. What is the ratio of the Expenses (% of total expenses) in Other expenses in 2005 to that in 2008?
Offer a terse response. 0.74. What is the ratio of the Expenses (% of total expenses) of Compensation of employees in 2006 to that in 2007?
Provide a short and direct response. 1.02. What is the ratio of the Expenses (% of total expenses) in Goods and services in 2006 to that in 2007?
Your answer should be compact. 0.96. What is the ratio of the Expenses (% of total expenses) in Other expenses in 2006 to that in 2007?
Make the answer very short. 1.02. What is the ratio of the Expenses (% of total expenses) in Compensation of employees in 2006 to that in 2008?
Your answer should be very brief. 1.16. What is the ratio of the Expenses (% of total expenses) of Goods and services in 2006 to that in 2008?
Keep it short and to the point. 1.11. What is the ratio of the Expenses (% of total expenses) in Subsidies and Transfers in 2006 to that in 2008?
Keep it short and to the point. 1.01. What is the ratio of the Expenses (% of total expenses) in Other expenses in 2006 to that in 2008?
Offer a very short reply. 0.82. What is the ratio of the Expenses (% of total expenses) in Compensation of employees in 2007 to that in 2008?
Ensure brevity in your answer.  1.14. What is the ratio of the Expenses (% of total expenses) in Goods and services in 2007 to that in 2008?
Your answer should be compact. 1.15. What is the ratio of the Expenses (% of total expenses) in Subsidies and Transfers in 2007 to that in 2008?
Your response must be concise. 1.01. What is the ratio of the Expenses (% of total expenses) in Other expenses in 2007 to that in 2008?
Provide a succinct answer. 0.81. What is the difference between the highest and the second highest Expenses (% of total expenses) in Compensation of employees?
Give a very brief answer. 0.25. What is the difference between the highest and the second highest Expenses (% of total expenses) in Goods and services?
Your response must be concise. 1.2. What is the difference between the highest and the second highest Expenses (% of total expenses) in Subsidies and Transfers?
Offer a terse response. 7.34. What is the difference between the highest and the second highest Expenses (% of total expenses) in Other expenses?
Your response must be concise. 6.68. What is the difference between the highest and the lowest Expenses (% of total expenses) of Compensation of employees?
Offer a very short reply. 3.6. What is the difference between the highest and the lowest Expenses (% of total expenses) in Goods and services?
Make the answer very short. 12.41. What is the difference between the highest and the lowest Expenses (% of total expenses) in Subsidies and Transfers?
Make the answer very short. 17.93. What is the difference between the highest and the lowest Expenses (% of total expenses) of Other expenses?
Ensure brevity in your answer.  9.76. 